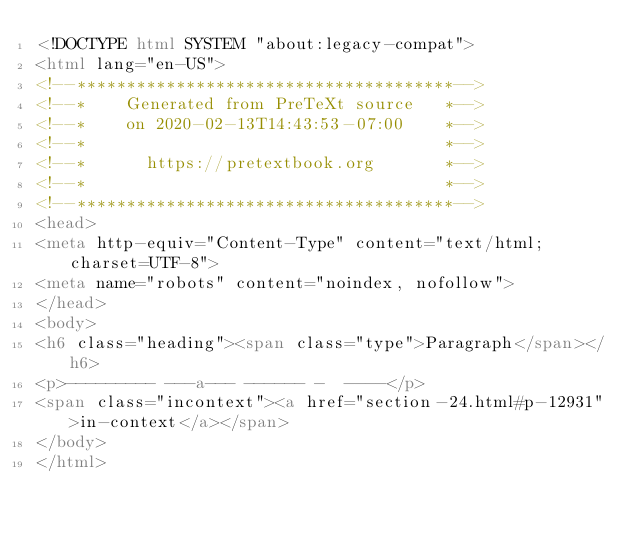<code> <loc_0><loc_0><loc_500><loc_500><_HTML_><!DOCTYPE html SYSTEM "about:legacy-compat">
<html lang="en-US">
<!--**************************************-->
<!--*    Generated from PreTeXt source   *-->
<!--*    on 2020-02-13T14:43:53-07:00    *-->
<!--*                                    *-->
<!--*      https://pretextbook.org       *-->
<!--*                                    *-->
<!--**************************************-->
<head>
<meta http-equiv="Content-Type" content="text/html; charset=UTF-8">
<meta name="robots" content="noindex, nofollow">
</head>
<body>
<h6 class="heading"><span class="type">Paragraph</span></h6>
<p>--------- ---a--- ------ -  ----</p>
<span class="incontext"><a href="section-24.html#p-12931">in-context</a></span>
</body>
</html>
</code> 